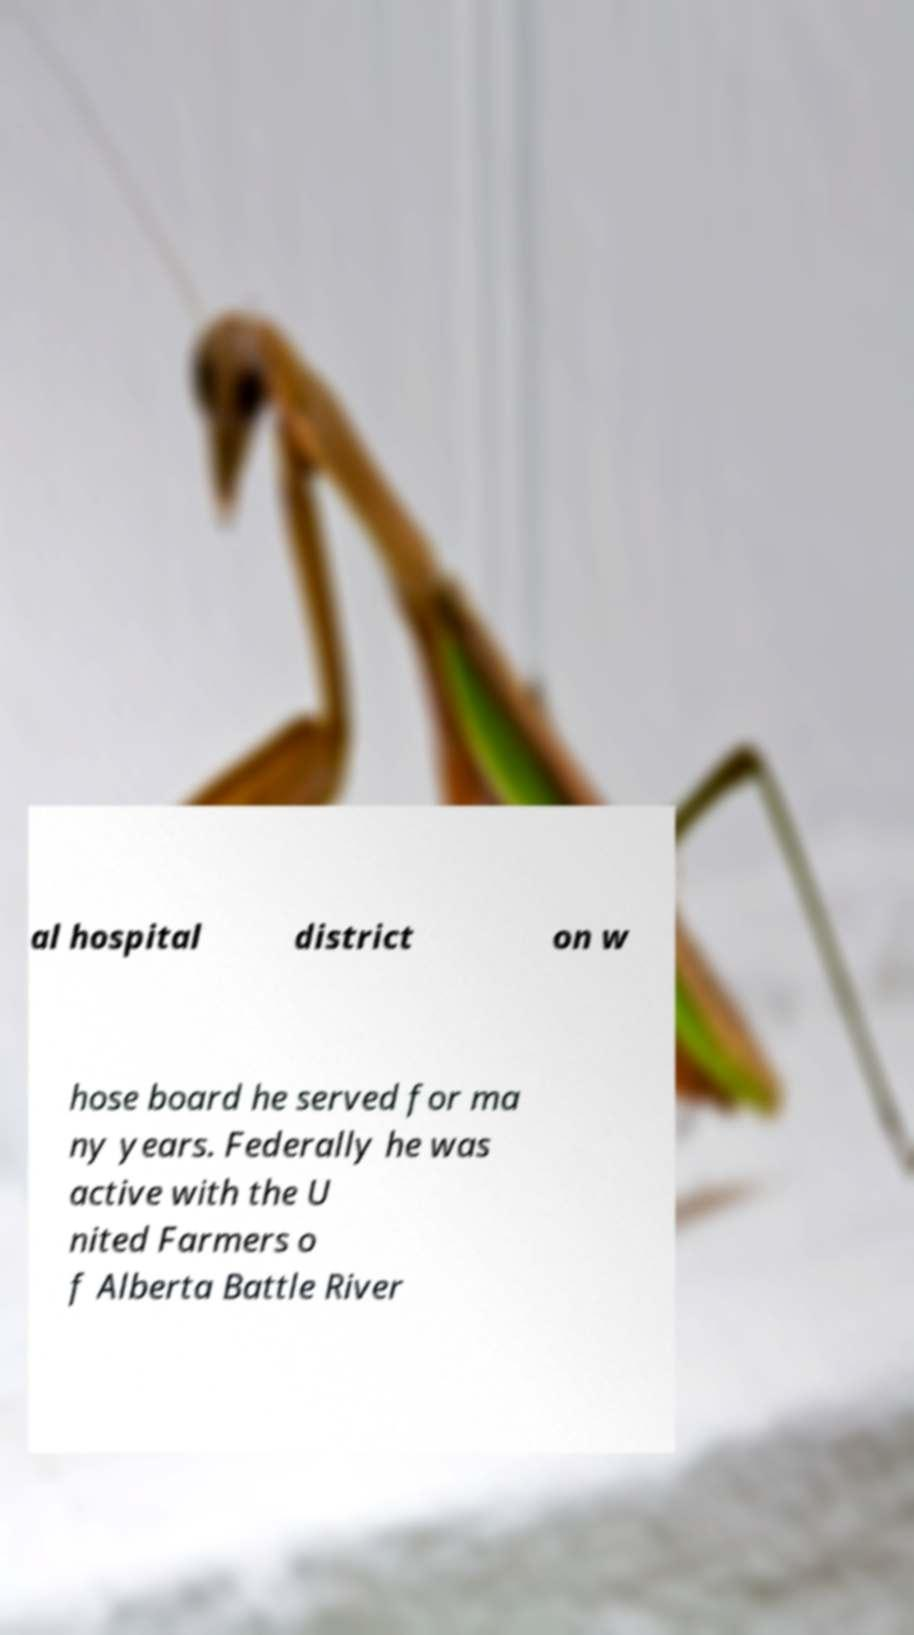Please identify and transcribe the text found in this image. al hospital district on w hose board he served for ma ny years. Federally he was active with the U nited Farmers o f Alberta Battle River 